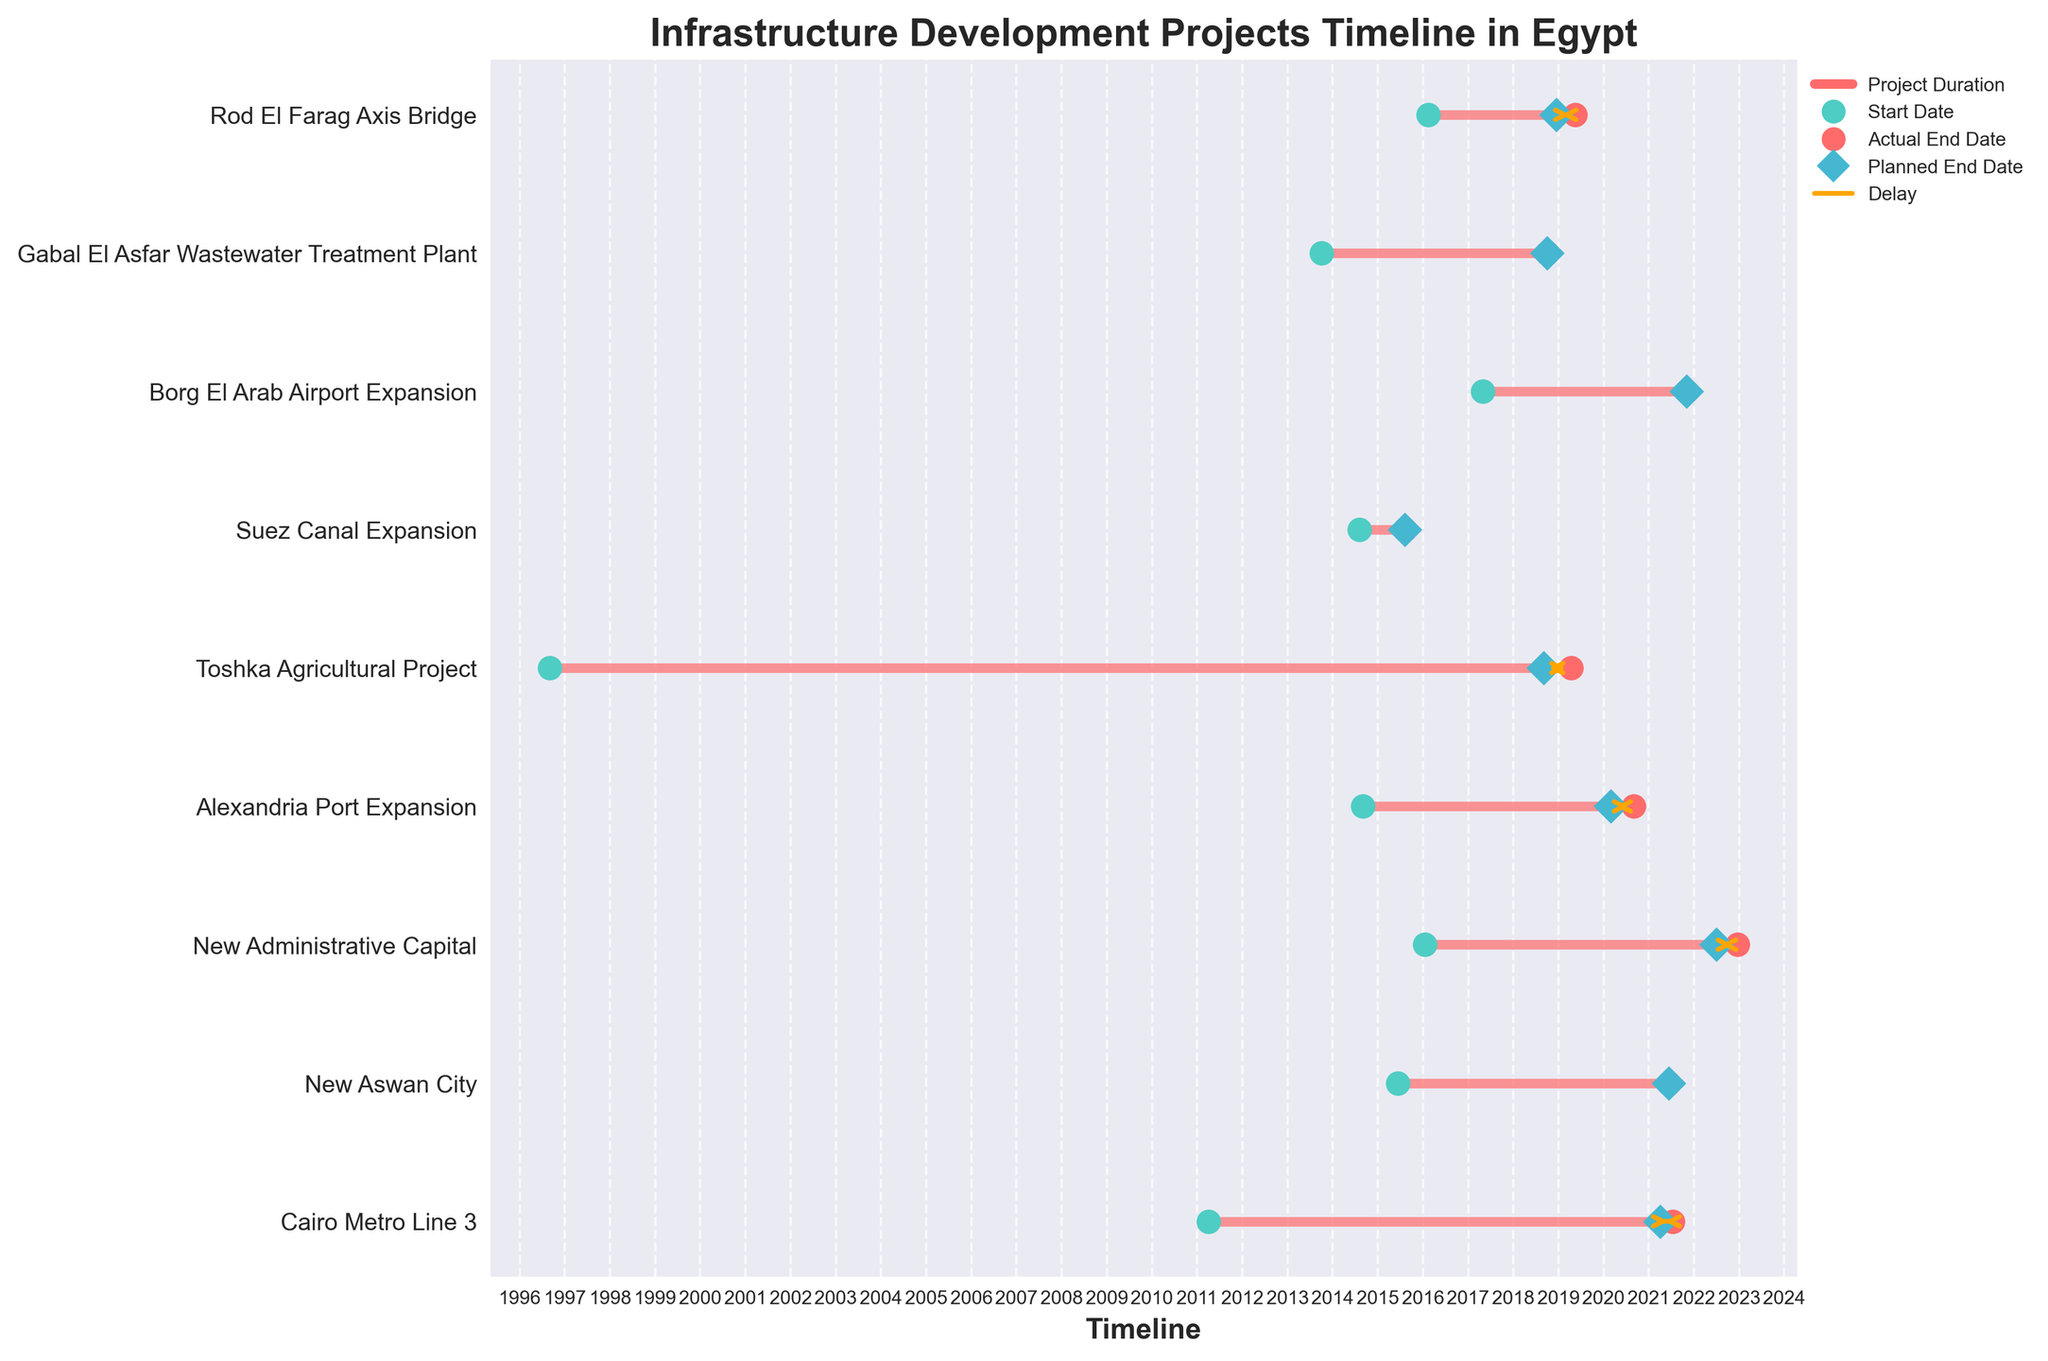What's the title of the figure? The title of the figure is generally placed at the top of the chart. In this case, it should be clearly written and provides an overview of what the figure is about.
Answer: Infrastructure Development Projects Timeline in Egypt How many projects are shown in the figure? Each horizontal line in the chart represents one project. By counting the number of horizontal lines, we can determine the total number of projects shown.
Answer: 9 Which projects were completed on time? Projects completed on time can be identified by looking for instances where the actual end date (red dot) matches the planned end date (blue diamond).
Answer: New Aswan City, Suez Canal Expansion, Borg El Arab Airport Expansion, Gabal El Asfar Wastewater Treatment Plant What project had the longest delay? To find the longest delay, look for the project with the longest orange arrow stretching between the planned end date (blue diamond) and the actual end date (red dot).
Answer: Toshka Agricultural Project Which project was completed earliest? The earliest completed project can be determined by finding the project with the earliest actual end date (red dot).
Answer: Suez Canal Expansion How many projects were delayed? Projects that were delayed can be identified by the presence of an orange arrow indicating the delay between the planned end date (blue diamond) and the actual end date (red dot).
Answer: 5 What is the average duration of the on-time completed projects? Calculate the duration (in years) of each on-time project by subtracting the start date from the end date, then average these durations.
Answer: 5.5 years (approximately) Which project started the earliest? Identify the project with the earliest start date (green dot).
Answer: Toshka Agricultural Project Compare the duration of the Cairo Metro Line 3 to the New Administrative Capital. Which one took longer? Calculate the duration of each project by subtracting the start date from the actual end date, then compare the durations. Cairo Metro Line 3: ~10.25 years; New Administrative Capital: ~6.9 years.
Answer: Cairo Metro Line 3 What proportion of the projects were completed on time versus delayed? To determine the proportion, count the number of on-time projects and the number of delayed projects, and divide each by the total number of projects. On-time: 4/9; Delayed: 5/9.
Answer: ~44% on time, ~56% delayed 